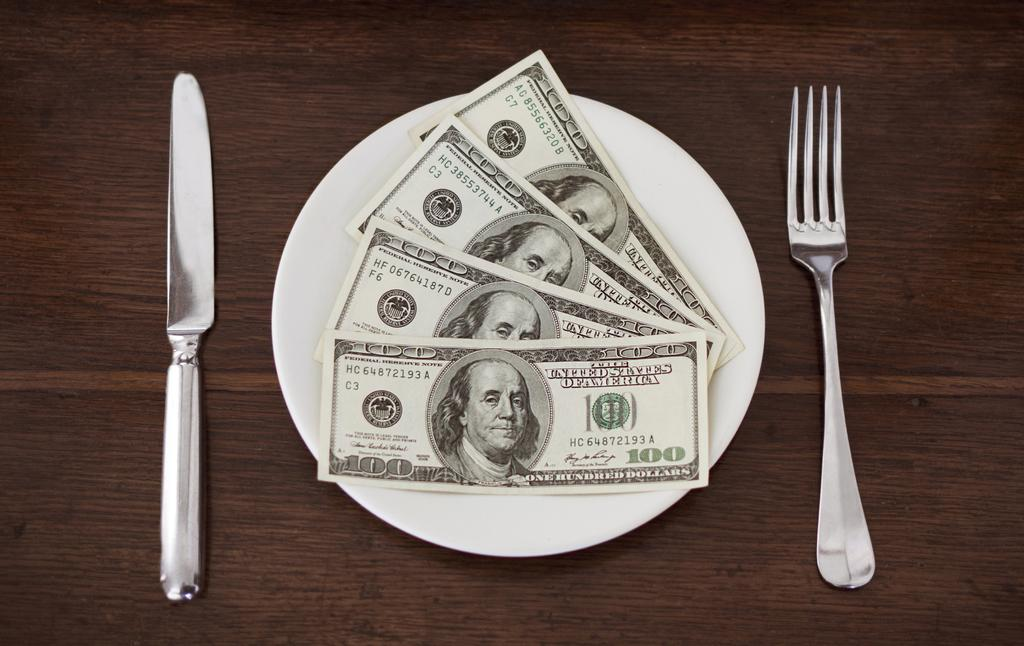What is present on the plate in the image? There is currency placed on a plate in the image. Where is the plate located? The plate is on a table in the image. What utensils can be seen in the image? There is a knife on the left side of the image and a fork on the right side of the image. How many icicles are hanging from the knife in the image? There are no icicles present in the image, as it is not a cold environment. 